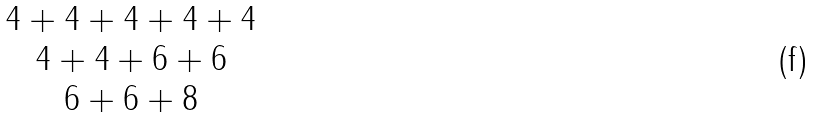<formula> <loc_0><loc_0><loc_500><loc_500>\begin{matrix} 4 + 4 + 4 + 4 + 4 \\ 4 + 4 + 6 + 6 \\ 6 + 6 + 8 \end{matrix}</formula> 